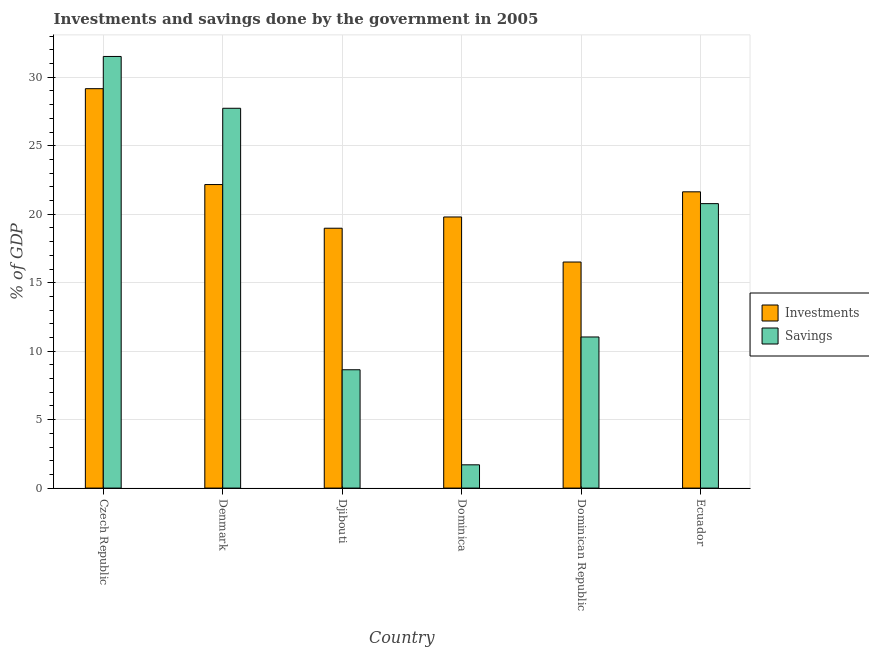How many different coloured bars are there?
Your answer should be very brief. 2. How many groups of bars are there?
Keep it short and to the point. 6. Are the number of bars on each tick of the X-axis equal?
Keep it short and to the point. Yes. How many bars are there on the 3rd tick from the left?
Your answer should be very brief. 2. What is the label of the 3rd group of bars from the left?
Provide a succinct answer. Djibouti. In how many cases, is the number of bars for a given country not equal to the number of legend labels?
Make the answer very short. 0. Across all countries, what is the maximum investments of government?
Offer a terse response. 29.17. Across all countries, what is the minimum investments of government?
Offer a very short reply. 16.51. In which country was the savings of government maximum?
Your response must be concise. Czech Republic. In which country was the savings of government minimum?
Ensure brevity in your answer.  Dominica. What is the total savings of government in the graph?
Provide a short and direct response. 101.41. What is the difference between the investments of government in Denmark and that in Dominica?
Give a very brief answer. 2.37. What is the difference between the investments of government in Ecuador and the savings of government in Djibouti?
Provide a short and direct response. 12.99. What is the average investments of government per country?
Provide a short and direct response. 21.38. What is the difference between the investments of government and savings of government in Czech Republic?
Ensure brevity in your answer.  -2.35. What is the ratio of the savings of government in Djibouti to that in Dominica?
Give a very brief answer. 5.08. Is the investments of government in Czech Republic less than that in Denmark?
Ensure brevity in your answer.  No. What is the difference between the highest and the second highest investments of government?
Your answer should be very brief. 7. What is the difference between the highest and the lowest investments of government?
Make the answer very short. 12.66. In how many countries, is the investments of government greater than the average investments of government taken over all countries?
Make the answer very short. 3. Is the sum of the investments of government in Czech Republic and Dominican Republic greater than the maximum savings of government across all countries?
Give a very brief answer. Yes. What does the 1st bar from the left in Djibouti represents?
Your response must be concise. Investments. What does the 1st bar from the right in Dominica represents?
Your answer should be compact. Savings. How many countries are there in the graph?
Provide a succinct answer. 6. What is the difference between two consecutive major ticks on the Y-axis?
Keep it short and to the point. 5. Does the graph contain any zero values?
Your answer should be compact. No. Does the graph contain grids?
Provide a short and direct response. Yes. Where does the legend appear in the graph?
Keep it short and to the point. Center right. How many legend labels are there?
Your answer should be compact. 2. How are the legend labels stacked?
Keep it short and to the point. Vertical. What is the title of the graph?
Ensure brevity in your answer.  Investments and savings done by the government in 2005. What is the label or title of the Y-axis?
Your response must be concise. % of GDP. What is the % of GDP in Investments in Czech Republic?
Provide a succinct answer. 29.17. What is the % of GDP of Savings in Czech Republic?
Your answer should be compact. 31.52. What is the % of GDP of Investments in Denmark?
Your answer should be compact. 22.17. What is the % of GDP in Savings in Denmark?
Offer a terse response. 27.74. What is the % of GDP of Investments in Djibouti?
Your answer should be compact. 18.98. What is the % of GDP of Savings in Djibouti?
Your answer should be compact. 8.64. What is the % of GDP of Investments in Dominica?
Ensure brevity in your answer.  19.8. What is the % of GDP in Savings in Dominica?
Make the answer very short. 1.7. What is the % of GDP in Investments in Dominican Republic?
Offer a terse response. 16.51. What is the % of GDP in Savings in Dominican Republic?
Your answer should be very brief. 11.04. What is the % of GDP of Investments in Ecuador?
Offer a terse response. 21.64. What is the % of GDP of Savings in Ecuador?
Your response must be concise. 20.77. Across all countries, what is the maximum % of GDP of Investments?
Your answer should be very brief. 29.17. Across all countries, what is the maximum % of GDP of Savings?
Your answer should be very brief. 31.52. Across all countries, what is the minimum % of GDP of Investments?
Offer a very short reply. 16.51. Across all countries, what is the minimum % of GDP of Savings?
Give a very brief answer. 1.7. What is the total % of GDP in Investments in the graph?
Your response must be concise. 128.26. What is the total % of GDP of Savings in the graph?
Provide a succinct answer. 101.41. What is the difference between the % of GDP of Investments in Czech Republic and that in Denmark?
Provide a succinct answer. 7. What is the difference between the % of GDP in Savings in Czech Republic and that in Denmark?
Offer a terse response. 3.78. What is the difference between the % of GDP in Investments in Czech Republic and that in Djibouti?
Your response must be concise. 10.19. What is the difference between the % of GDP of Savings in Czech Republic and that in Djibouti?
Offer a terse response. 22.88. What is the difference between the % of GDP of Investments in Czech Republic and that in Dominica?
Give a very brief answer. 9.37. What is the difference between the % of GDP of Savings in Czech Republic and that in Dominica?
Your answer should be very brief. 29.82. What is the difference between the % of GDP in Investments in Czech Republic and that in Dominican Republic?
Your answer should be compact. 12.66. What is the difference between the % of GDP in Savings in Czech Republic and that in Dominican Republic?
Offer a very short reply. 20.49. What is the difference between the % of GDP of Investments in Czech Republic and that in Ecuador?
Offer a terse response. 7.53. What is the difference between the % of GDP in Savings in Czech Republic and that in Ecuador?
Offer a very short reply. 10.75. What is the difference between the % of GDP in Investments in Denmark and that in Djibouti?
Your response must be concise. 3.19. What is the difference between the % of GDP in Savings in Denmark and that in Djibouti?
Provide a succinct answer. 19.1. What is the difference between the % of GDP in Investments in Denmark and that in Dominica?
Provide a succinct answer. 2.37. What is the difference between the % of GDP of Savings in Denmark and that in Dominica?
Keep it short and to the point. 26.04. What is the difference between the % of GDP of Investments in Denmark and that in Dominican Republic?
Keep it short and to the point. 5.66. What is the difference between the % of GDP of Savings in Denmark and that in Dominican Republic?
Give a very brief answer. 16.7. What is the difference between the % of GDP in Investments in Denmark and that in Ecuador?
Offer a terse response. 0.53. What is the difference between the % of GDP of Savings in Denmark and that in Ecuador?
Your answer should be compact. 6.96. What is the difference between the % of GDP in Investments in Djibouti and that in Dominica?
Provide a short and direct response. -0.82. What is the difference between the % of GDP of Savings in Djibouti and that in Dominica?
Your response must be concise. 6.94. What is the difference between the % of GDP in Investments in Djibouti and that in Dominican Republic?
Make the answer very short. 2.47. What is the difference between the % of GDP of Savings in Djibouti and that in Dominican Republic?
Offer a very short reply. -2.39. What is the difference between the % of GDP in Investments in Djibouti and that in Ecuador?
Provide a succinct answer. -2.66. What is the difference between the % of GDP in Savings in Djibouti and that in Ecuador?
Make the answer very short. -12.13. What is the difference between the % of GDP in Investments in Dominica and that in Dominican Republic?
Your answer should be compact. 3.29. What is the difference between the % of GDP of Savings in Dominica and that in Dominican Republic?
Make the answer very short. -9.34. What is the difference between the % of GDP of Investments in Dominica and that in Ecuador?
Provide a short and direct response. -1.84. What is the difference between the % of GDP of Savings in Dominica and that in Ecuador?
Give a very brief answer. -19.07. What is the difference between the % of GDP in Investments in Dominican Republic and that in Ecuador?
Offer a very short reply. -5.13. What is the difference between the % of GDP in Savings in Dominican Republic and that in Ecuador?
Your answer should be compact. -9.74. What is the difference between the % of GDP of Investments in Czech Republic and the % of GDP of Savings in Denmark?
Offer a terse response. 1.43. What is the difference between the % of GDP in Investments in Czech Republic and the % of GDP in Savings in Djibouti?
Offer a terse response. 20.53. What is the difference between the % of GDP of Investments in Czech Republic and the % of GDP of Savings in Dominica?
Make the answer very short. 27.47. What is the difference between the % of GDP in Investments in Czech Republic and the % of GDP in Savings in Dominican Republic?
Your answer should be compact. 18.13. What is the difference between the % of GDP in Investments in Czech Republic and the % of GDP in Savings in Ecuador?
Give a very brief answer. 8.4. What is the difference between the % of GDP of Investments in Denmark and the % of GDP of Savings in Djibouti?
Your answer should be very brief. 13.52. What is the difference between the % of GDP of Investments in Denmark and the % of GDP of Savings in Dominica?
Provide a short and direct response. 20.47. What is the difference between the % of GDP in Investments in Denmark and the % of GDP in Savings in Dominican Republic?
Provide a short and direct response. 11.13. What is the difference between the % of GDP in Investments in Denmark and the % of GDP in Savings in Ecuador?
Ensure brevity in your answer.  1.39. What is the difference between the % of GDP in Investments in Djibouti and the % of GDP in Savings in Dominica?
Make the answer very short. 17.28. What is the difference between the % of GDP of Investments in Djibouti and the % of GDP of Savings in Dominican Republic?
Ensure brevity in your answer.  7.94. What is the difference between the % of GDP of Investments in Djibouti and the % of GDP of Savings in Ecuador?
Your answer should be very brief. -1.8. What is the difference between the % of GDP of Investments in Dominica and the % of GDP of Savings in Dominican Republic?
Your answer should be compact. 8.76. What is the difference between the % of GDP in Investments in Dominica and the % of GDP in Savings in Ecuador?
Offer a terse response. -0.97. What is the difference between the % of GDP in Investments in Dominican Republic and the % of GDP in Savings in Ecuador?
Offer a very short reply. -4.26. What is the average % of GDP of Investments per country?
Your response must be concise. 21.38. What is the average % of GDP in Savings per country?
Make the answer very short. 16.9. What is the difference between the % of GDP of Investments and % of GDP of Savings in Czech Republic?
Provide a short and direct response. -2.35. What is the difference between the % of GDP in Investments and % of GDP in Savings in Denmark?
Provide a succinct answer. -5.57. What is the difference between the % of GDP of Investments and % of GDP of Savings in Djibouti?
Provide a succinct answer. 10.34. What is the difference between the % of GDP in Investments and % of GDP in Savings in Dominica?
Offer a terse response. 18.1. What is the difference between the % of GDP in Investments and % of GDP in Savings in Dominican Republic?
Give a very brief answer. 5.47. What is the difference between the % of GDP in Investments and % of GDP in Savings in Ecuador?
Your answer should be very brief. 0.86. What is the ratio of the % of GDP in Investments in Czech Republic to that in Denmark?
Offer a terse response. 1.32. What is the ratio of the % of GDP in Savings in Czech Republic to that in Denmark?
Provide a short and direct response. 1.14. What is the ratio of the % of GDP in Investments in Czech Republic to that in Djibouti?
Your response must be concise. 1.54. What is the ratio of the % of GDP of Savings in Czech Republic to that in Djibouti?
Keep it short and to the point. 3.65. What is the ratio of the % of GDP in Investments in Czech Republic to that in Dominica?
Offer a terse response. 1.47. What is the ratio of the % of GDP in Savings in Czech Republic to that in Dominica?
Your answer should be very brief. 18.54. What is the ratio of the % of GDP in Investments in Czech Republic to that in Dominican Republic?
Your answer should be very brief. 1.77. What is the ratio of the % of GDP in Savings in Czech Republic to that in Dominican Republic?
Provide a short and direct response. 2.86. What is the ratio of the % of GDP of Investments in Czech Republic to that in Ecuador?
Your response must be concise. 1.35. What is the ratio of the % of GDP of Savings in Czech Republic to that in Ecuador?
Provide a short and direct response. 1.52. What is the ratio of the % of GDP in Investments in Denmark to that in Djibouti?
Your answer should be very brief. 1.17. What is the ratio of the % of GDP of Savings in Denmark to that in Djibouti?
Provide a succinct answer. 3.21. What is the ratio of the % of GDP in Investments in Denmark to that in Dominica?
Keep it short and to the point. 1.12. What is the ratio of the % of GDP in Savings in Denmark to that in Dominica?
Give a very brief answer. 16.32. What is the ratio of the % of GDP of Investments in Denmark to that in Dominican Republic?
Keep it short and to the point. 1.34. What is the ratio of the % of GDP in Savings in Denmark to that in Dominican Republic?
Offer a very short reply. 2.51. What is the ratio of the % of GDP in Investments in Denmark to that in Ecuador?
Keep it short and to the point. 1.02. What is the ratio of the % of GDP in Savings in Denmark to that in Ecuador?
Make the answer very short. 1.34. What is the ratio of the % of GDP in Investments in Djibouti to that in Dominica?
Your response must be concise. 0.96. What is the ratio of the % of GDP of Savings in Djibouti to that in Dominica?
Your answer should be very brief. 5.08. What is the ratio of the % of GDP in Investments in Djibouti to that in Dominican Republic?
Give a very brief answer. 1.15. What is the ratio of the % of GDP in Savings in Djibouti to that in Dominican Republic?
Offer a terse response. 0.78. What is the ratio of the % of GDP in Investments in Djibouti to that in Ecuador?
Provide a succinct answer. 0.88. What is the ratio of the % of GDP in Savings in Djibouti to that in Ecuador?
Provide a short and direct response. 0.42. What is the ratio of the % of GDP of Investments in Dominica to that in Dominican Republic?
Offer a very short reply. 1.2. What is the ratio of the % of GDP of Savings in Dominica to that in Dominican Republic?
Your answer should be very brief. 0.15. What is the ratio of the % of GDP of Investments in Dominica to that in Ecuador?
Your answer should be very brief. 0.92. What is the ratio of the % of GDP of Savings in Dominica to that in Ecuador?
Ensure brevity in your answer.  0.08. What is the ratio of the % of GDP in Investments in Dominican Republic to that in Ecuador?
Your answer should be very brief. 0.76. What is the ratio of the % of GDP in Savings in Dominican Republic to that in Ecuador?
Make the answer very short. 0.53. What is the difference between the highest and the second highest % of GDP in Investments?
Offer a very short reply. 7. What is the difference between the highest and the second highest % of GDP in Savings?
Provide a succinct answer. 3.78. What is the difference between the highest and the lowest % of GDP of Investments?
Your response must be concise. 12.66. What is the difference between the highest and the lowest % of GDP of Savings?
Your answer should be very brief. 29.82. 